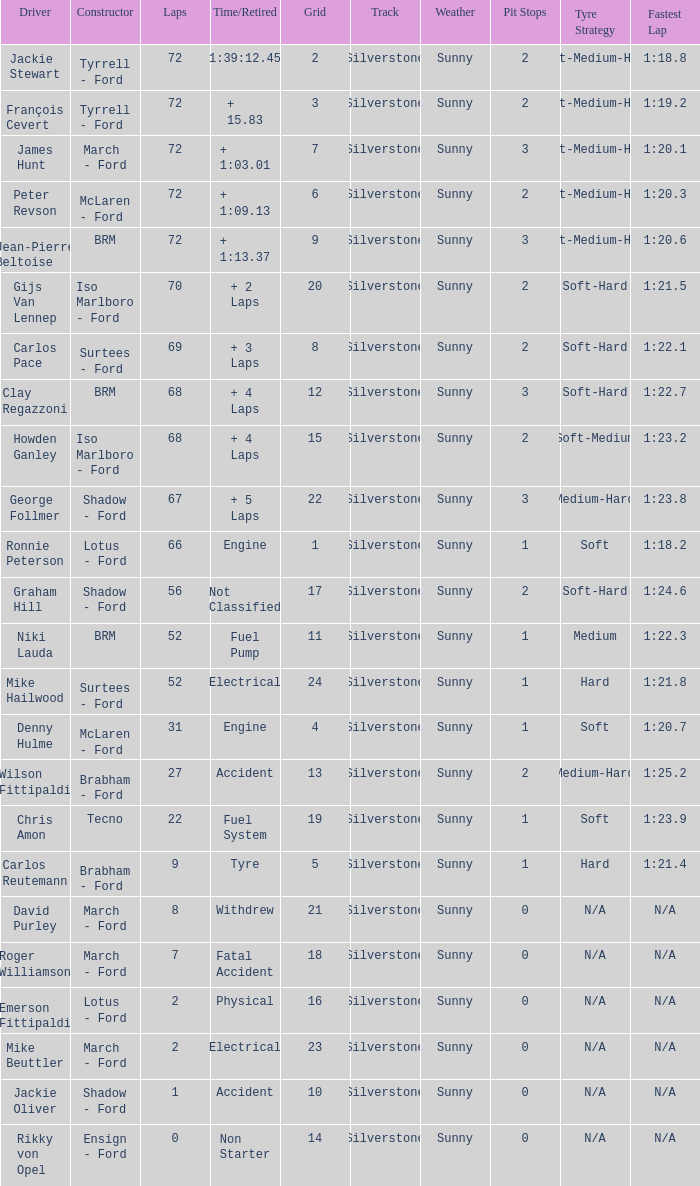What is the top grid that roger williamson lapped less than 7? None. 